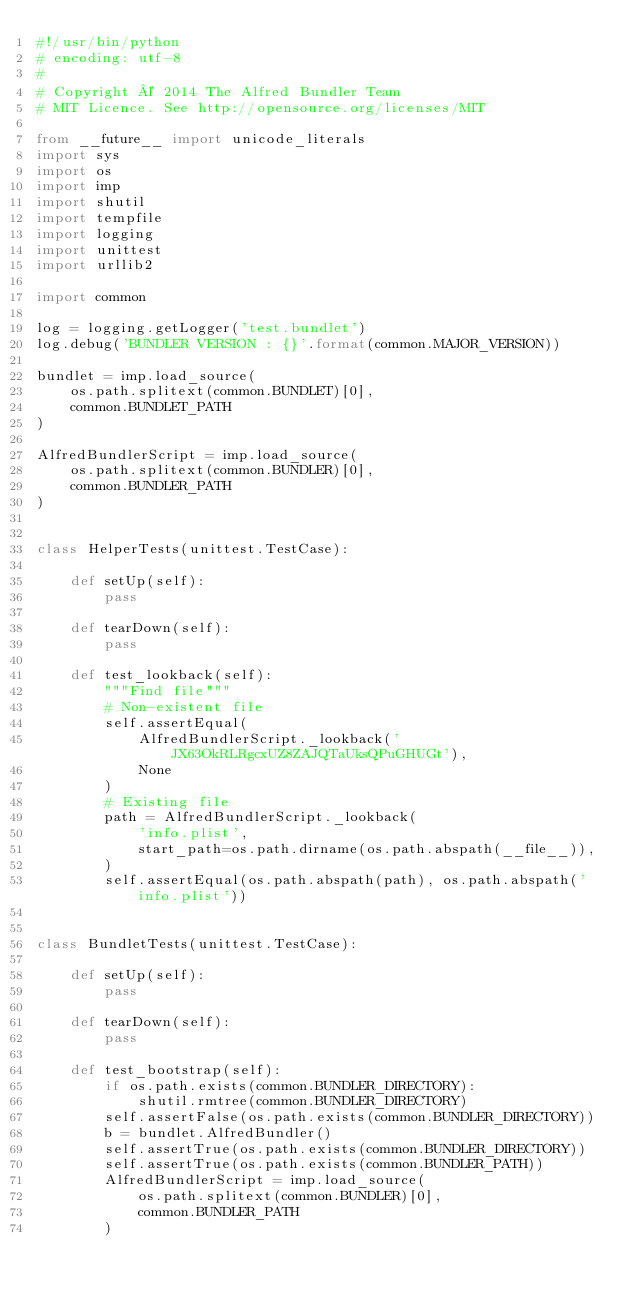<code> <loc_0><loc_0><loc_500><loc_500><_Python_>#!/usr/bin/python
# encoding: utf-8
#
# Copyright © 2014 The Alfred Bundler Team
# MIT Licence. See http://opensource.org/licenses/MIT

from __future__ import unicode_literals
import sys
import os
import imp
import shutil
import tempfile
import logging
import unittest
import urllib2

import common

log = logging.getLogger('test.bundlet')
log.debug('BUNDLER VERSION : {}'.format(common.MAJOR_VERSION))

bundlet = imp.load_source(
    os.path.splitext(common.BUNDLET)[0],
    common.BUNDLET_PATH
)

AlfredBundlerScript = imp.load_source(
    os.path.splitext(common.BUNDLER)[0],
    common.BUNDLER_PATH
)


class HelperTests(unittest.TestCase):

    def setUp(self):
        pass

    def tearDown(self):
        pass

    def test_lookback(self):
        """Find file"""
        # Non-existent file
        self.assertEqual(
            AlfredBundlerScript._lookback('JX63OkRLRgcxUZ8ZAJQTaUksQPuGHUGt'),
            None
        )
        # Existing file
        path = AlfredBundlerScript._lookback(
            'info.plist',
            start_path=os.path.dirname(os.path.abspath(__file__)),
        )
        self.assertEqual(os.path.abspath(path), os.path.abspath('info.plist'))


class BundletTests(unittest.TestCase):

    def setUp(self):
        pass

    def tearDown(self):
        pass

    def test_bootstrap(self):
        if os.path.exists(common.BUNDLER_DIRECTORY):
            shutil.rmtree(common.BUNDLER_DIRECTORY)
        self.assertFalse(os.path.exists(common.BUNDLER_DIRECTORY))
        b = bundlet.AlfredBundler()
        self.assertTrue(os.path.exists(common.BUNDLER_DIRECTORY))
        self.assertTrue(os.path.exists(common.BUNDLER_PATH))
        AlfredBundlerScript = imp.load_source(
            os.path.splitext(common.BUNDLER)[0],
            common.BUNDLER_PATH
        )</code> 